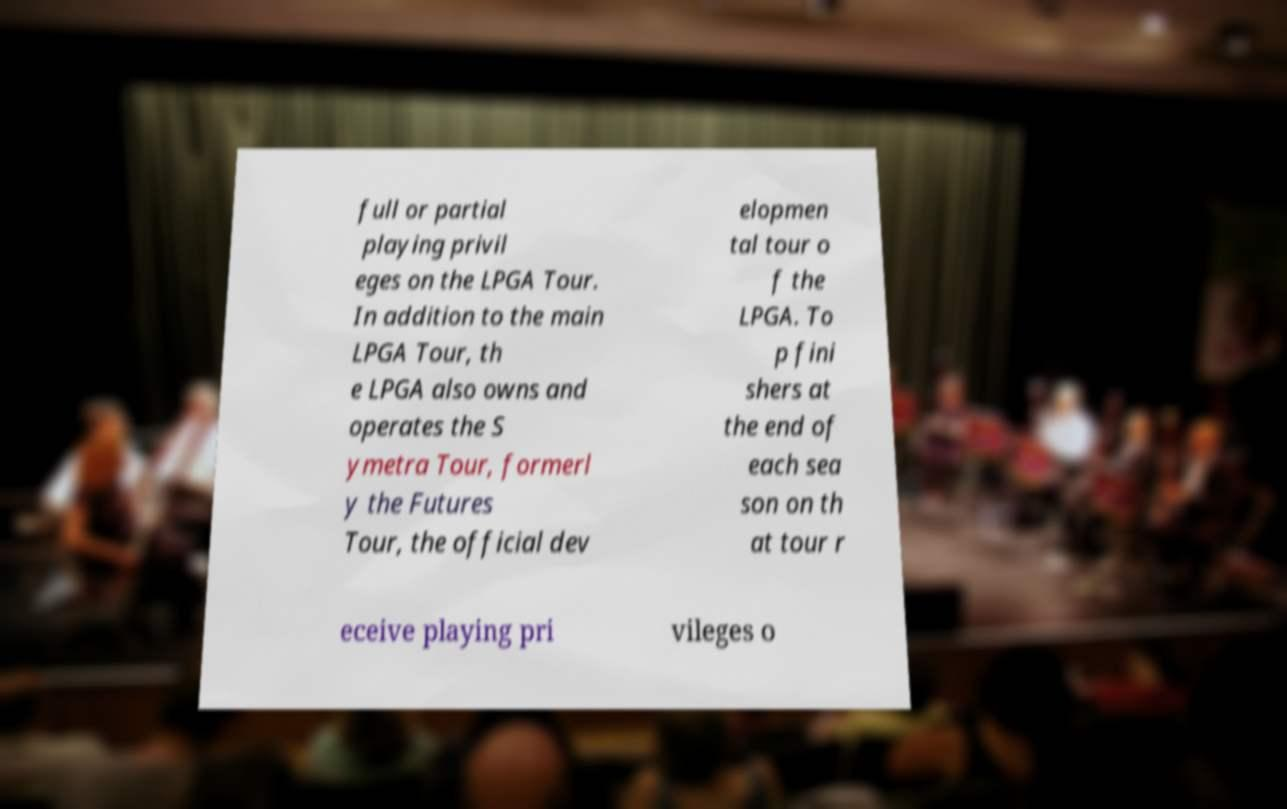Could you assist in decoding the text presented in this image and type it out clearly? full or partial playing privil eges on the LPGA Tour. In addition to the main LPGA Tour, th e LPGA also owns and operates the S ymetra Tour, formerl y the Futures Tour, the official dev elopmen tal tour o f the LPGA. To p fini shers at the end of each sea son on th at tour r eceive playing pri vileges o 